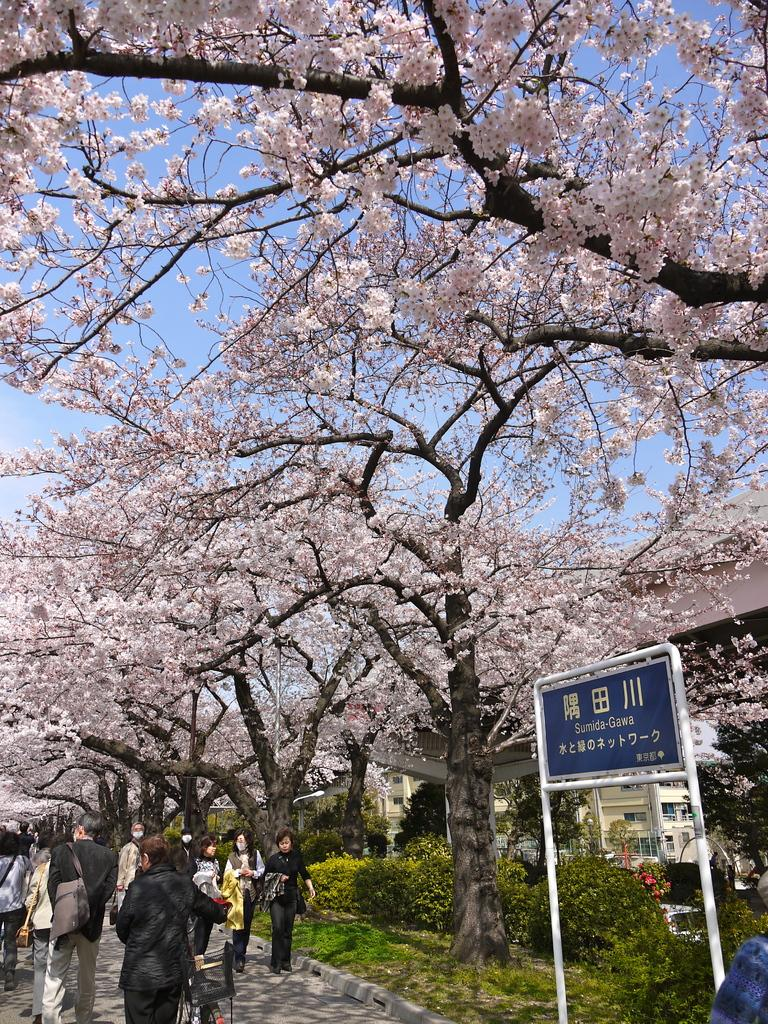What are the people in the image doing? The people in the image are walking. Where are the people walking? The people are walking on a path. What can be seen beside the path? There is grass, plants, and trees beside the path. What is on the right side of the path? There is a board with notations on the right side of the path. What type of thread is being used to commit a crime in the image? There is no thread or crime present in the image; it features people walking on a path surrounded by grass, plants, trees, and a board with notations. 